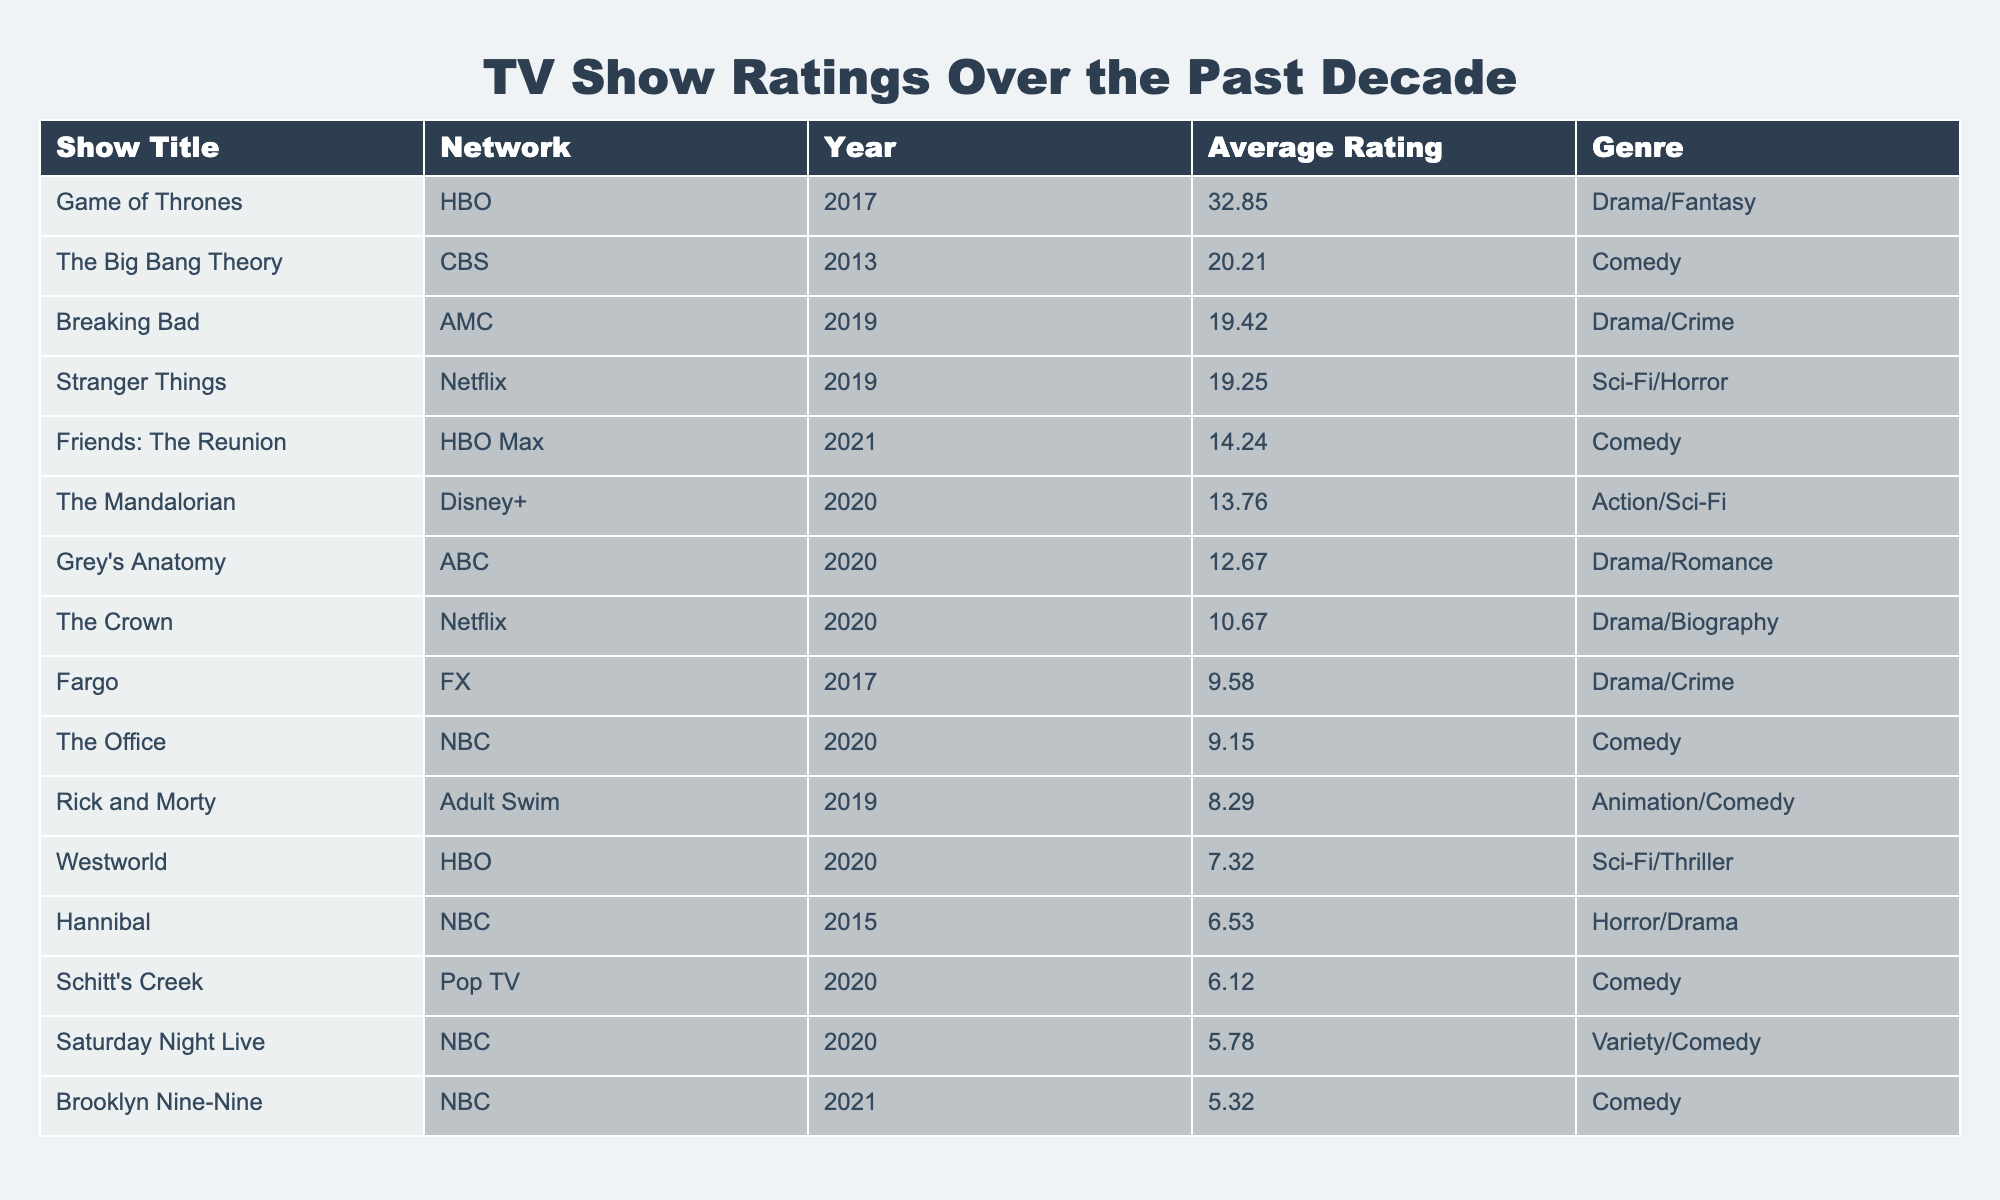What was the show with the highest average rating? The table shows "Game of Thrones" with an average rating of 32.85, which is the highest compared to all other shows listed.
Answer: Game of Thrones Which network aired "Breaking Bad"? The table indicates that "Breaking Bad" was aired on AMC.
Answer: AMC Which genre has the lowest-rated show in the table? "Schitt's Creek," categorized as Comedy, has the lowest average rating of 6.12.
Answer: Comedy What is the average rating of shows aired on HBO? The shows aired on HBO are "Game of Thrones," "Friends: The Reunion," and "Westworld." Their average ratings are (32.85 + 14.24 + 7.32) / 3 = 18.80.
Answer: 18.80 Is "The Mandalorian" rated higher than "Grey's Anatomy"? "The Mandalorian" has an average rating of 13.76, while "Grey's Anatomy" has a lower rating of 12.67, making the statement true.
Answer: Yes What is the difference between the highest and lowest average ratings? The highest rating is 32.85 for "Game of Thrones," and the lowest is 5.32 for "Brooklyn Nine-Nine." The difference is 32.85 - 5.32 = 27.53.
Answer: 27.53 How many shows have an average rating above 15? The shows that rate above 15 are "Game of Thrones," "The Big Bang Theory," and "Breaking Bad." There are three such shows.
Answer: 3 Which genre had the most shows listed in the table, and how many of them had a rating above 10? Comedy is the genre with the most shows: "The Big Bang Theory," "Friends: The Reunion," "Schitt's Creek," "Rick and Morty," "Brooklyn Nine-Nine," and "The Office." Out of these, "The Big Bang Theory," "Friends: The Reunion," and "The Office" have ratings above 10, totaling three shows.
Answer: Comedy, 3 What percentage of shows have an average rating below 10? There are a total of 15 shows. The shows below an average rating of 10 are "Schitt's Creek," "Brooklyn Nine-Nine," "Rick and Morty," "Hannibal," and "Saturday Night Live," totaling five shows. The percentage is (5 / 15) * 100 = 33.33%.
Answer: 33.33% Are there any shows from Netflix that have an average rating below 15? The table shows "Stranger Things" (19.25) and "The Crown" (10.67), where "The Crown" is below 15, making the statement true.
Answer: Yes 